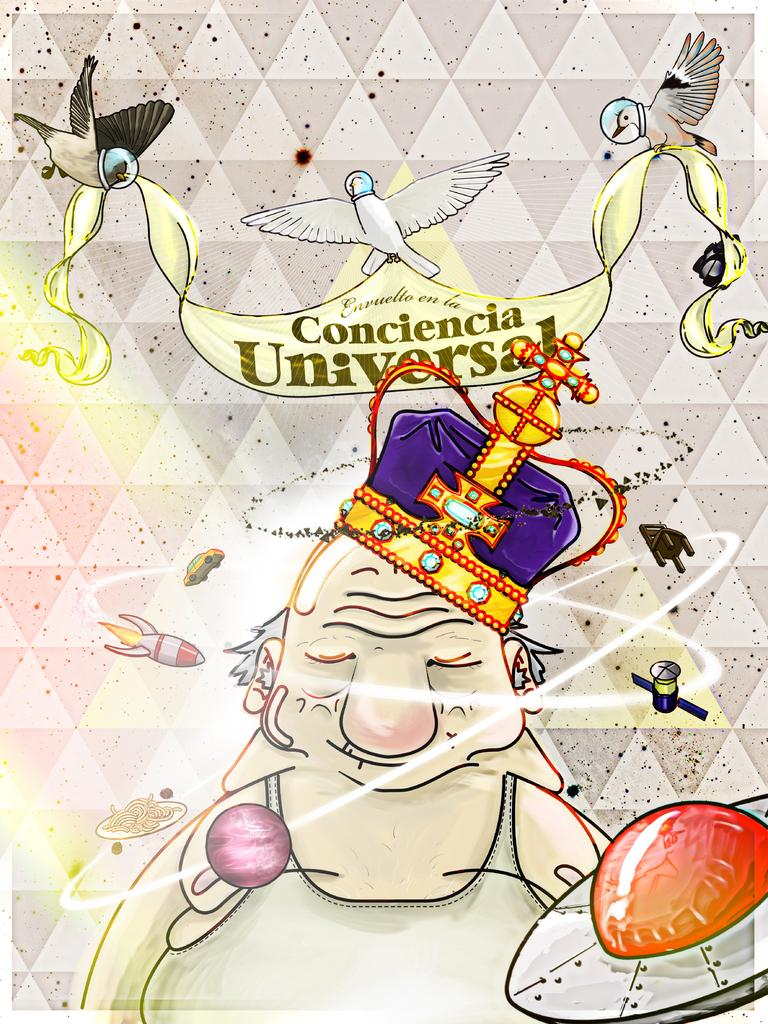What is present on the poster in the image? There is a poster in the image, which contains a cartoon image and images of birds. What type of images are depicted on the poster? The poster contains a cartoon image and images of birds. Is there any text on the poster? Yes, there is text written on the poster. How many geese are visible in the bath on the poster? There are no geese or bath present on the poster; it contains a cartoon image and images of birds. 